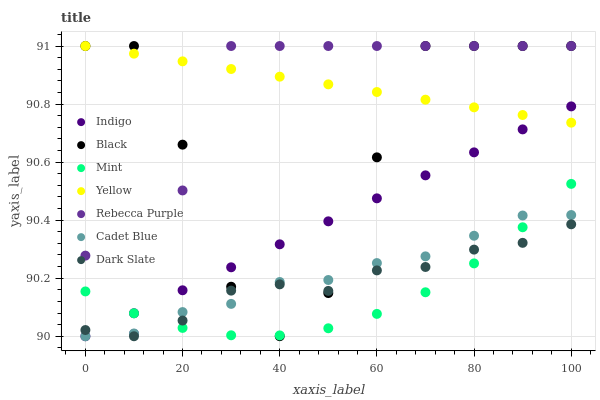Does Mint have the minimum area under the curve?
Answer yes or no. Yes. Does Yellow have the maximum area under the curve?
Answer yes or no. Yes. Does Indigo have the minimum area under the curve?
Answer yes or no. No. Does Indigo have the maximum area under the curve?
Answer yes or no. No. Is Indigo the smoothest?
Answer yes or no. Yes. Is Black the roughest?
Answer yes or no. Yes. Is Yellow the smoothest?
Answer yes or no. No. Is Yellow the roughest?
Answer yes or no. No. Does Cadet Blue have the lowest value?
Answer yes or no. Yes. Does Yellow have the lowest value?
Answer yes or no. No. Does Rebecca Purple have the highest value?
Answer yes or no. Yes. Does Indigo have the highest value?
Answer yes or no. No. Is Mint less than Yellow?
Answer yes or no. Yes. Is Yellow greater than Cadet Blue?
Answer yes or no. Yes. Does Mint intersect Rebecca Purple?
Answer yes or no. Yes. Is Mint less than Rebecca Purple?
Answer yes or no. No. Is Mint greater than Rebecca Purple?
Answer yes or no. No. Does Mint intersect Yellow?
Answer yes or no. No. 